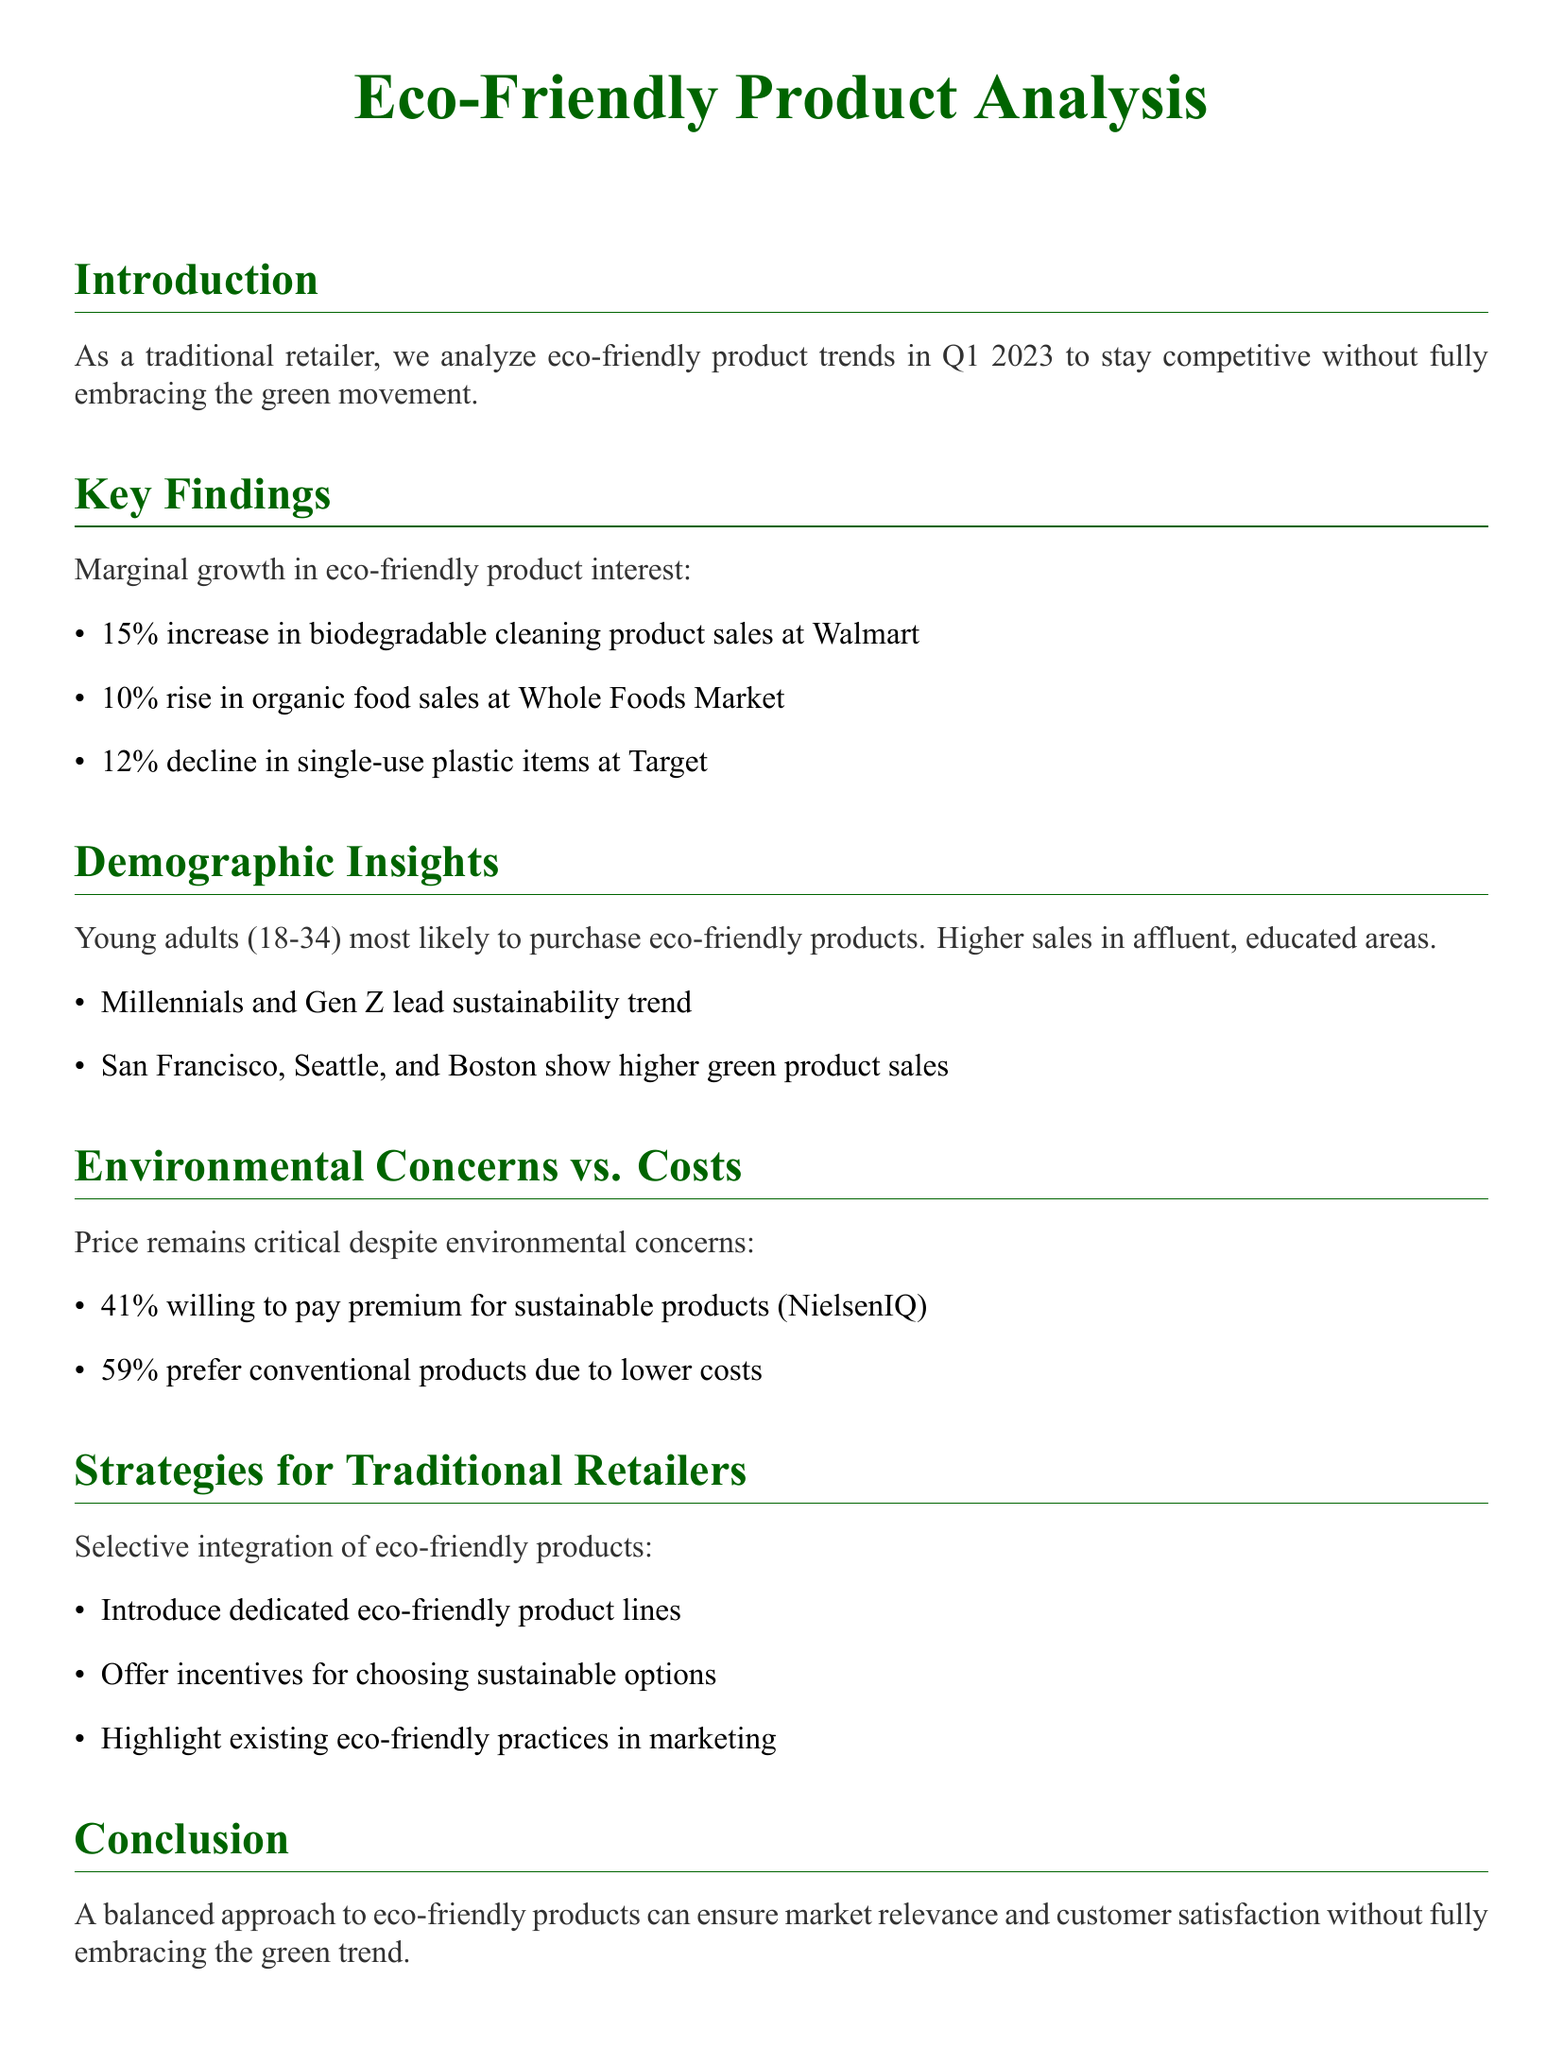what is the percentage increase in biodegradable cleaning product sales? The document states a 15% increase in biodegradable cleaning product sales at Walmart.
Answer: 15% which demographic group is most likely to purchase eco-friendly products? The document indicates that Young adults (18-34) are the most likely to purchase eco-friendly products.
Answer: Young adults (18-34) what percentage of consumers are willing to pay a premium for sustainable products? According to the document, 41% of consumers are willing to pay a premium for sustainable products.
Answer: 41% which city shows higher green product sales? The document lists San Francisco as a city with higher green product sales.
Answer: San Francisco what is the percentage decline in single-use plastic items at Target? The document reports a 12% decline in single-use plastic items at Target.
Answer: 12% which retailer experienced a 10% rise in organic food sales? The document mentions Whole Foods Market as the retailer with a 10% rise in organic food sales.
Answer: Whole Foods Market what is the main marketing strategy suggested for traditional retailers? The document suggests introducing dedicated eco-friendly product lines as a main strategy.
Answer: Introduce dedicated eco-friendly product lines what is the preference of consumers towards conventional products? The document states that 59% of consumers prefer conventional products due to lower costs.
Answer: 59% what is the main approach suggested for traditional retailers regarding eco-friendly products? The document concludes that a balanced approach can ensure market relevance.
Answer: A balanced approach 